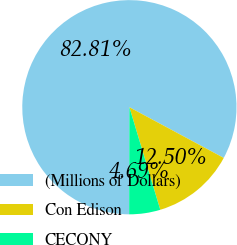<chart> <loc_0><loc_0><loc_500><loc_500><pie_chart><fcel>(Millions of Dollars)<fcel>Con Edison<fcel>CECONY<nl><fcel>82.82%<fcel>12.5%<fcel>4.69%<nl></chart> 